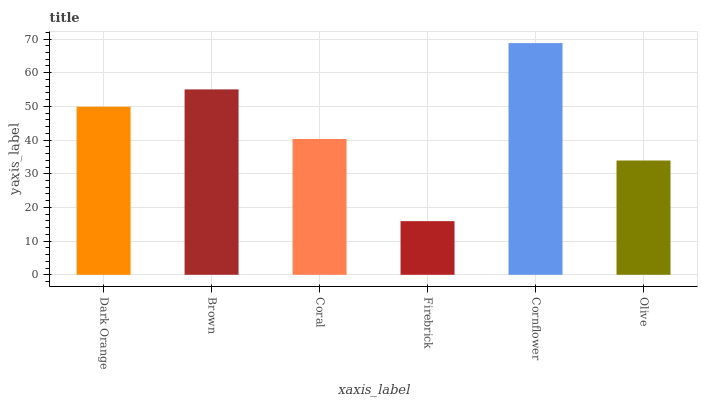Is Firebrick the minimum?
Answer yes or no. Yes. Is Cornflower the maximum?
Answer yes or no. Yes. Is Brown the minimum?
Answer yes or no. No. Is Brown the maximum?
Answer yes or no. No. Is Brown greater than Dark Orange?
Answer yes or no. Yes. Is Dark Orange less than Brown?
Answer yes or no. Yes. Is Dark Orange greater than Brown?
Answer yes or no. No. Is Brown less than Dark Orange?
Answer yes or no. No. Is Dark Orange the high median?
Answer yes or no. Yes. Is Coral the low median?
Answer yes or no. Yes. Is Brown the high median?
Answer yes or no. No. Is Olive the low median?
Answer yes or no. No. 